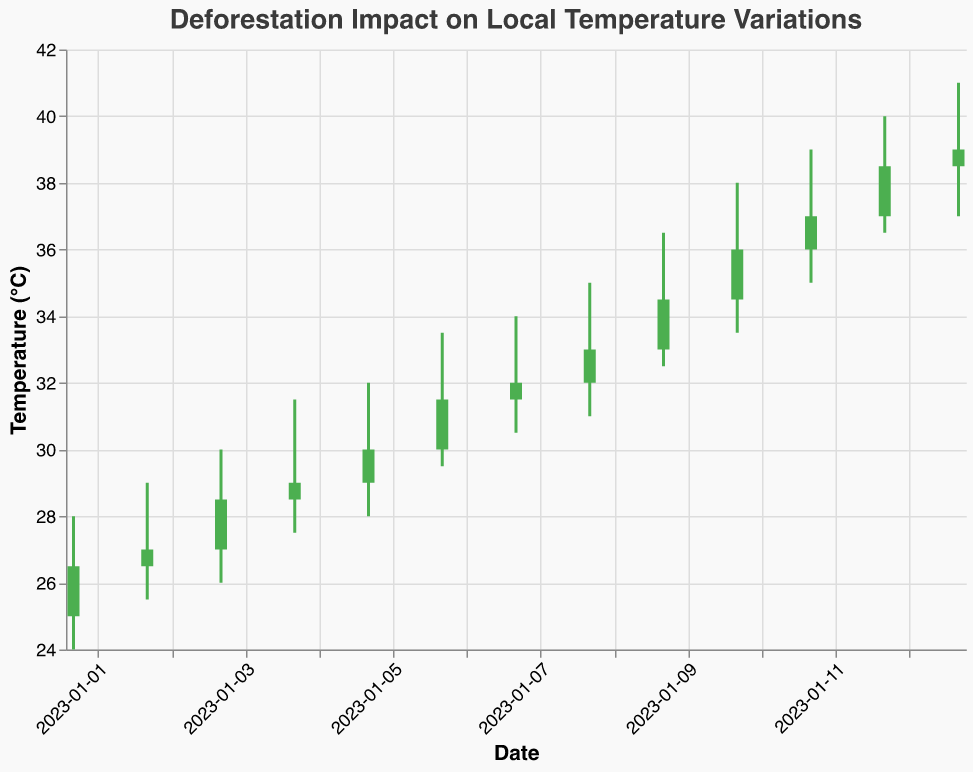what is the main title of the figure? The main title can be seen at the top of the figure, which indicates the overall subject matter. The title reads "Deforestation Impact on Local Temperature Variations".
Answer: Deforestation Impact on Local Temperature Variations What are the three highest recorded temperatures, and on which dates were they taken? To find this, look for the highest points on the y-axis corresponding to the "High" values. The three highest recorded temperatures are 41.0, taken on 2023-01-13, 40.0, taken on 2023-01-12, and 39.0, taken on 2023-01-11.
Answer: 41.0 on 2023-01-13, 40.0 on 2023-01-12, 39.0 on 2023-01-11 What is the overall trend in temperature changes from January 1st to January 13th, 2023? To discern the overall trend, observe the changes in the closing prices from the start date to the end date. Starting at 26.5 on January 1st and ending at 39.0 on January 13th, the overall trend is an increase in temperature.
Answer: Increase Which region has the largest appearance of data points and how many? To determine this, count how many times each region appears in the dataset. "Amazon_Rainforest" and "Congo_Rainforest" both appear four times.
Answer: Amazon_Rainforest and Congo_Rainforest, 4 times each What is the average closing temperature across all data points? To find this, sum up all the closing temperatures and divide by the number of data points. The sum of closing temperatures is 415, and there are 13 data points. The average is 415/13 ≈ 31.92.
Answer: 31.92 On which dates did the Amazon Rainforest show an increase in temperature? Refer to the dates for the Amazon Rainforest and compare the closing temperatures with the preceding opening temperatures to see if they increased. The dates with an increase are 2023-01-01 (26.5 > 24.0) and 2023-01-11 (37.0 > 35.0).
Answer: 2023-01-01 and 2023-01-11 Which day has the largest change between the "High" and "Low" temperatures? Calculate the differences for each date by subtracting the "Low" from the "High" and find the maximum value. The largest change is on 2023-01-12, with 40.0 - 36.5 = 3.5.
Answer: 2023-01-12 How many bars in the figure are represented in green color? Green indicates days when the closing price is higher than the opening price. Count how many bars fulfill this criterion. There are 9 green bars.
Answer: 9 On which date did the Congo Rainforest show the highest closing temperature? For the Congo Rainforest, compare the closing temperatures to find the highest one. The highest closing temperature is 39.0 on 2023-01-13.
Answer: 2023-01-13 